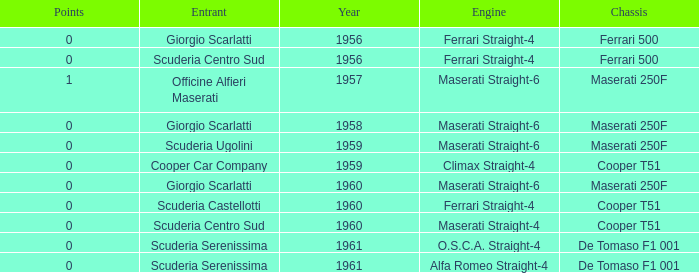How many points for the cooper car company after 1959? None. 